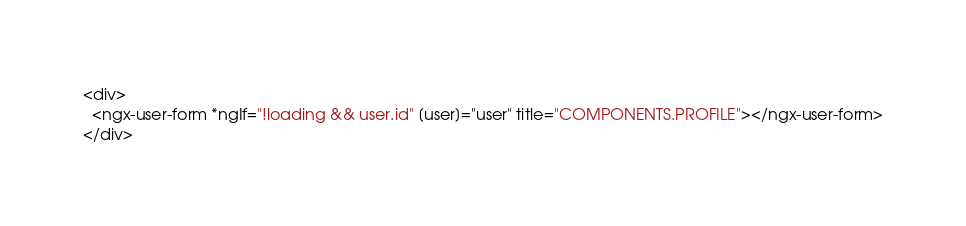<code> <loc_0><loc_0><loc_500><loc_500><_HTML_><div>
  <ngx-user-form *ngIf="!loading && user.id" [user]="user" title="COMPONENTS.PROFILE"></ngx-user-form>
</div></code> 